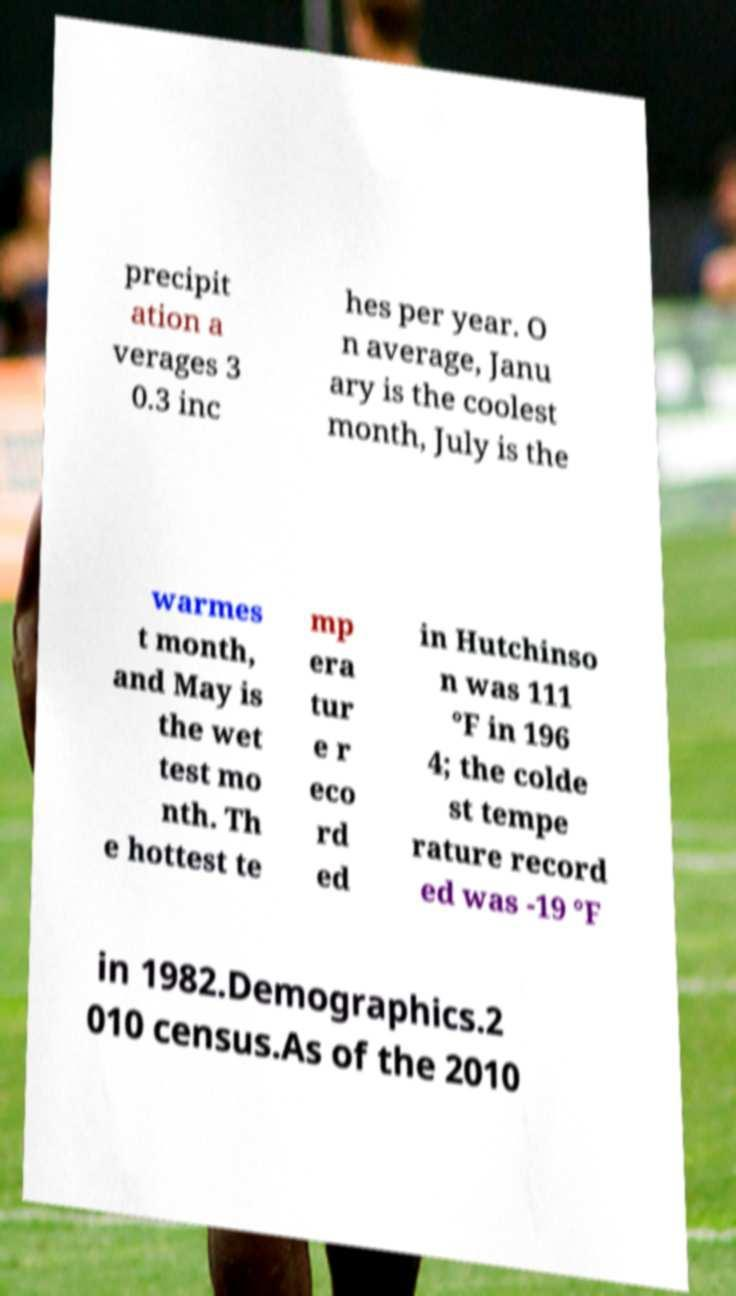I need the written content from this picture converted into text. Can you do that? precipit ation a verages 3 0.3 inc hes per year. O n average, Janu ary is the coolest month, July is the warmes t month, and May is the wet test mo nth. Th e hottest te mp era tur e r eco rd ed in Hutchinso n was 111 °F in 196 4; the colde st tempe rature record ed was -19 °F in 1982.Demographics.2 010 census.As of the 2010 